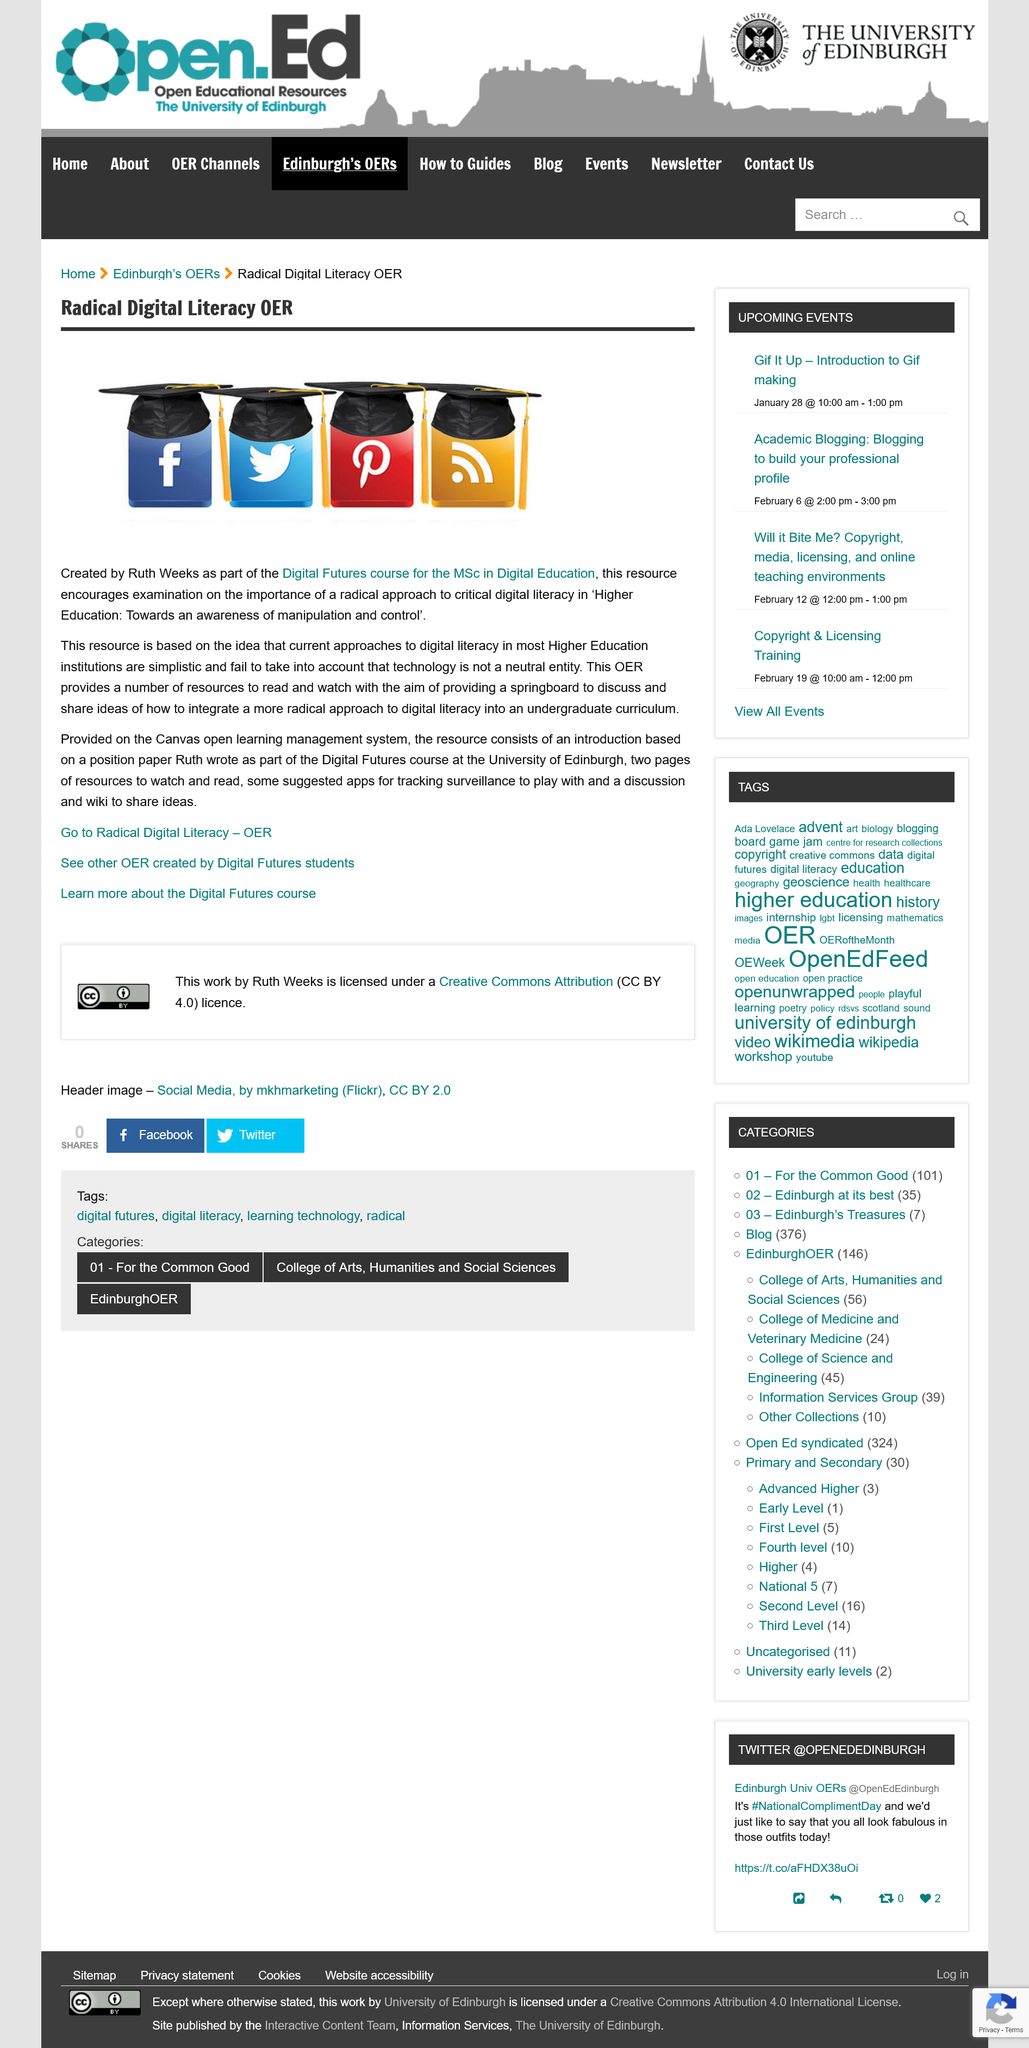Highlight a few significant elements in this photo. In the image, four technology companies are represented. Ruth Weeks wrote as part of the Digital Futures course at the University of Edinburgh. Ruth Weeks created the resource mentioned. 